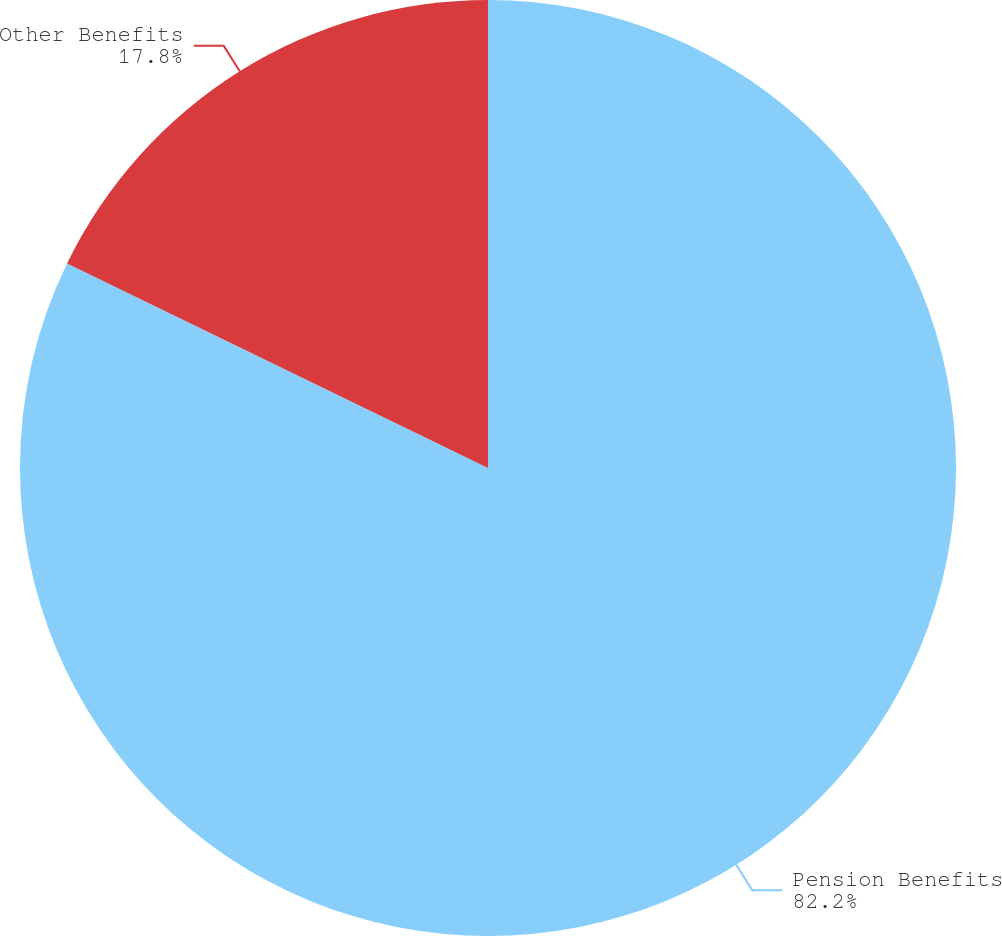Convert chart. <chart><loc_0><loc_0><loc_500><loc_500><pie_chart><fcel>Pension Benefits<fcel>Other Benefits<nl><fcel>82.2%<fcel>17.8%<nl></chart> 